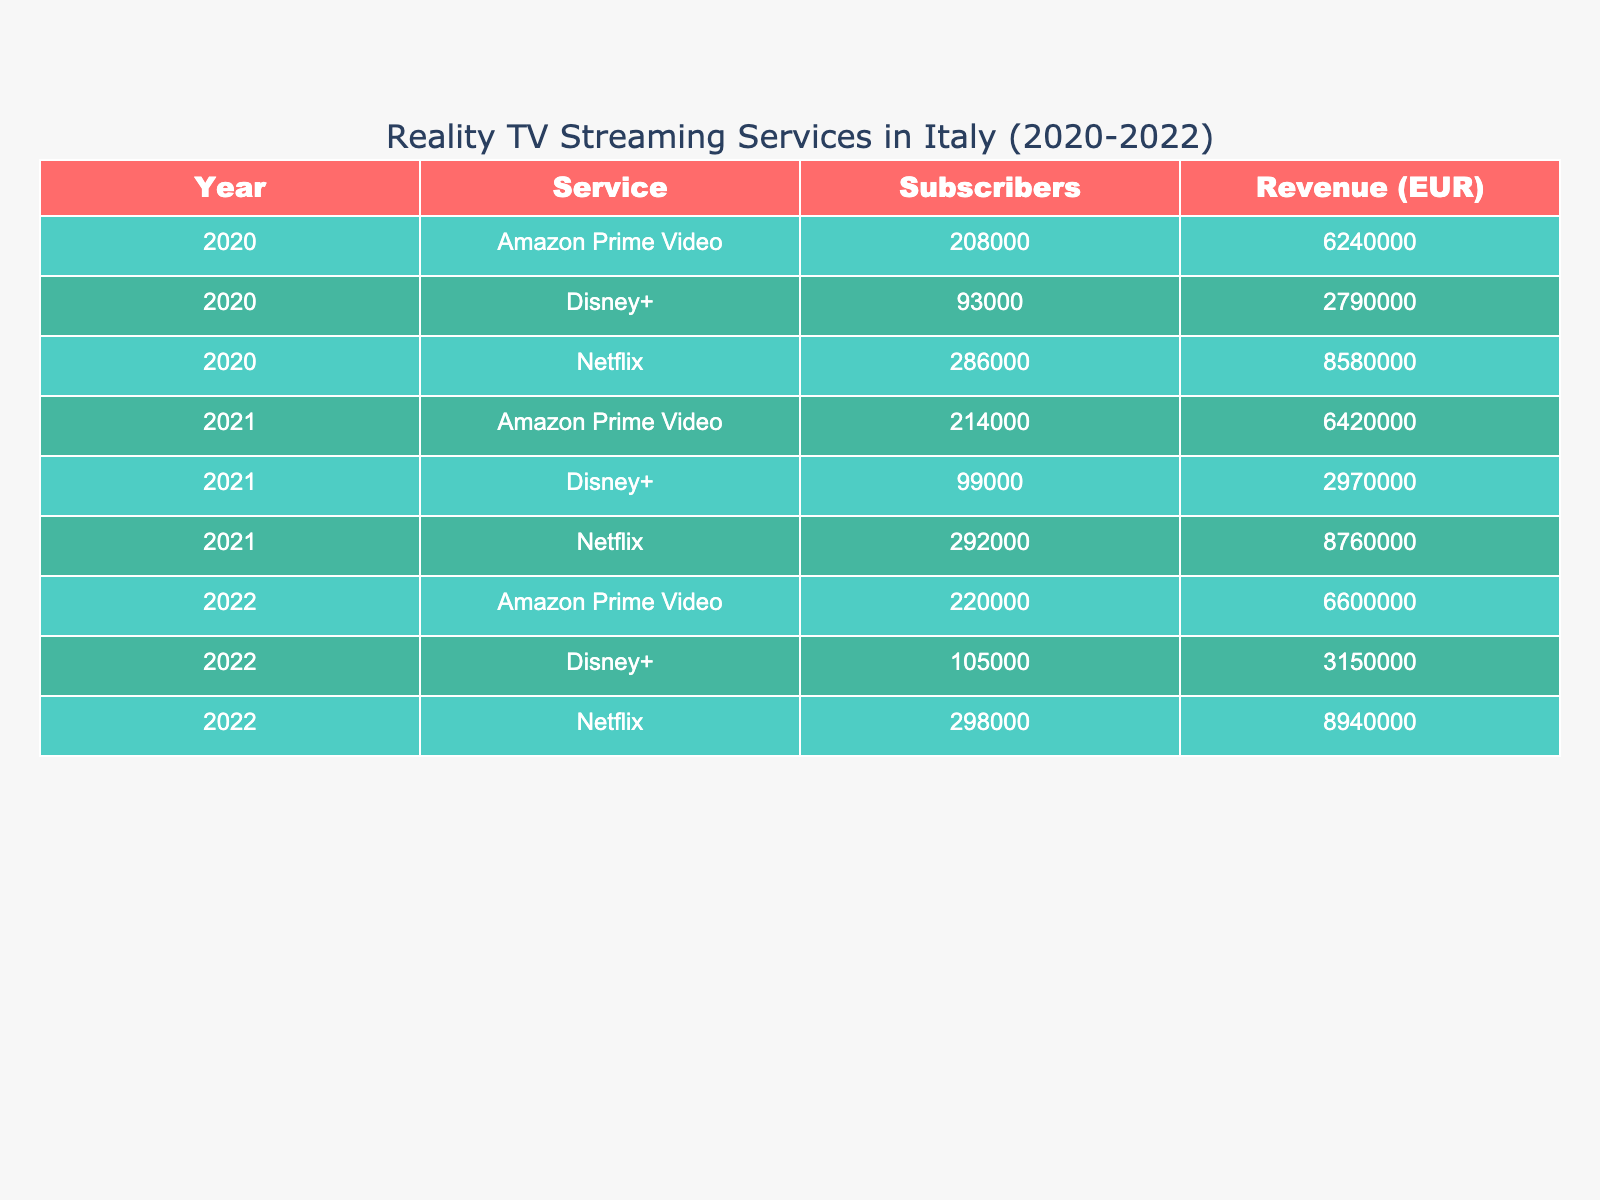What was the total number of subscribers for Netflix in 2020? To find the total number of subscribers for Netflix in 2020, we can look at the rows corresponding to Netflix for that year. The numbers are 45000 (Females) and 42000 (Males), so we add them: 45000 + 42000 = 87000.
Answer: 87000 Which streaming service had the highest subscription revenue in 2021? By examining the subscription revenue for each service in 2021, we find Netflix with 6,510,000 EUR, Amazon Prime Video with 4,380,000 EUR, and Disney+ with 2,190,000 EUR. Since Netflix's revenue is the highest, it had the highest subscription revenue in 2021.
Answer: Netflix What is the average number of subscribers for Disney+ in 2022 across all age groups? For Disney+ in 2022, the number of subscribers in each age group is 17000 (18-24), 22000 (25-34), and 14000 (35-44). To find the average, we sum these values: 17000 + 22000 + 14000 = 53000, then divide by the number of age groups (3): 53000 / 3 = 17667.
Answer: 17667 Did Amazon Prime Video have more subscribers than Disney+ in the 35-44 age group in any year? In 2020, Amazon Prime Video had 22000 subscribers while Disney+ had 11000 subscribers. In 2021, Amazon Prime had 23000 compared to Disney+'s 12000. In 2022, Amazon Prime had 24000 versus Disney+'s 13000. Hence, Amazon Prime Video had more subscribers in the 35-44 age group every year.
Answer: Yes What was the percentage increase in subscription revenue for Netflix from 2020 to 2022? The subscription revenue for Netflix in 2020 was 6,240,000 EUR (sum of males and females across all age groups), and in 2022 it was 6,870,000 EUR. To find the increase: 6,870,000 - 6,240,000 = 630,000. Then, divide that increase by the original amount: 630,000 / 6,240,000 ≈ 0.10096. Converting to percentage gives us approximately 10.1%.
Answer: 10.1% How many total subscribers did Netflix have in the 25-34 age group across all years? For Netflix across the years: In 2020, it had 138000 (sum of 70000 and 68000), in 2021 it had 140000 (71000 + 69000), and in 2022 it had 142000 (72000 + 70000). We then add these totals: 138000 + 140000 + 142000 = 420000.
Answer: 420000 